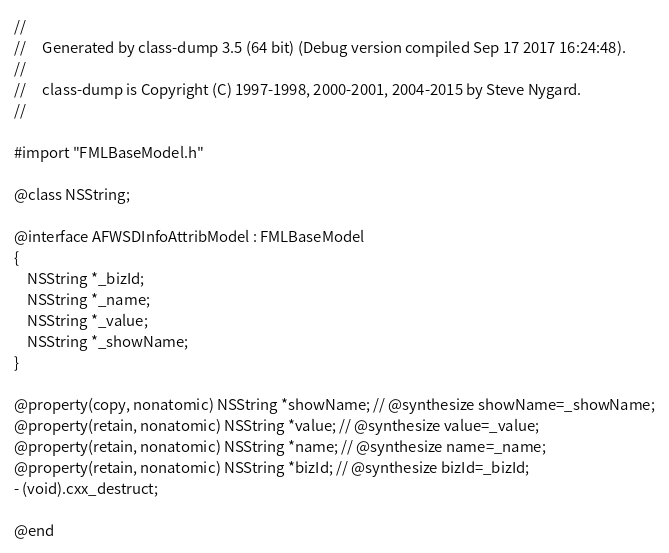Convert code to text. <code><loc_0><loc_0><loc_500><loc_500><_C_>//
//     Generated by class-dump 3.5 (64 bit) (Debug version compiled Sep 17 2017 16:24:48).
//
//     class-dump is Copyright (C) 1997-1998, 2000-2001, 2004-2015 by Steve Nygard.
//

#import "FMLBaseModel.h"

@class NSString;

@interface AFWSDInfoAttribModel : FMLBaseModel
{
    NSString *_bizId;
    NSString *_name;
    NSString *_value;
    NSString *_showName;
}

@property(copy, nonatomic) NSString *showName; // @synthesize showName=_showName;
@property(retain, nonatomic) NSString *value; // @synthesize value=_value;
@property(retain, nonatomic) NSString *name; // @synthesize name=_name;
@property(retain, nonatomic) NSString *bizId; // @synthesize bizId=_bizId;
- (void).cxx_destruct;

@end

</code> 